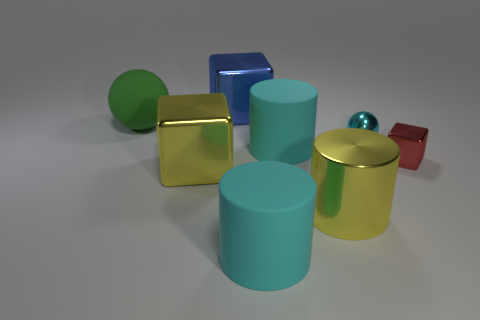Is the number of yellow metal blocks less than the number of big cyan shiny spheres?
Your response must be concise. No. There is a cube that is behind the tiny ball; how big is it?
Your response must be concise. Large. There is a large object that is to the left of the big yellow metallic cylinder and in front of the big yellow block; what is its shape?
Your answer should be very brief. Cylinder. What size is the other rubber thing that is the same shape as the tiny cyan thing?
Keep it short and to the point. Large. What number of large balls are made of the same material as the big blue block?
Your answer should be compact. 0. There is a metal ball; does it have the same color as the matte object that is in front of the large yellow block?
Your response must be concise. Yes. Is the number of large metallic cubes greater than the number of yellow metallic cubes?
Keep it short and to the point. Yes. The large metallic cylinder has what color?
Offer a very short reply. Yellow. Does the big shiny block that is in front of the small cyan metallic sphere have the same color as the small metallic sphere?
Ensure brevity in your answer.  No. What material is the cube that is the same color as the big metallic cylinder?
Provide a succinct answer. Metal. 